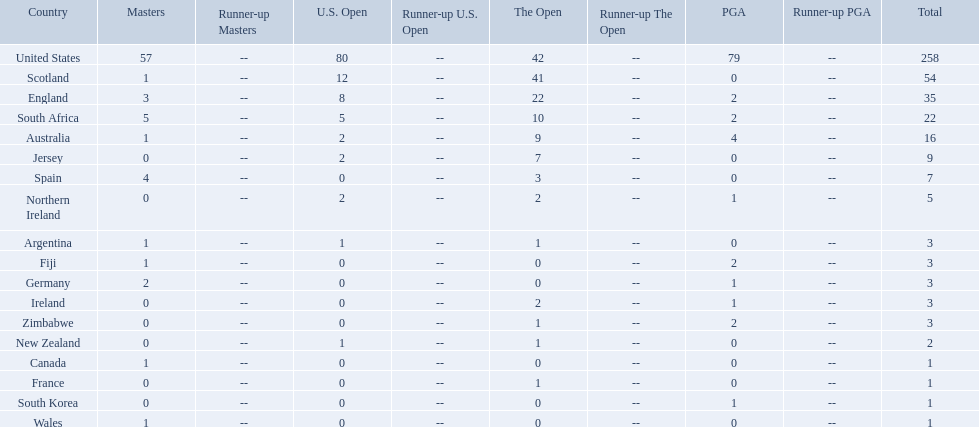Could you help me parse every detail presented in this table? {'header': ['Country', 'Masters', 'Runner-up Masters', 'U.S. Open', 'Runner-up U.S. Open', 'The Open', 'Runner-up The Open', 'PGA', 'Runner-up PGA', 'Total'], 'rows': [['United States', '57', '--', '80', '--', '42', '--', '79', '--', '258'], ['Scotland', '1', '--', '12', '--', '41', '--', '0', '--', '54'], ['England', '3', '--', '8', '--', '22', '--', '2', '--', '35'], ['South Africa', '5', '--', '5', '--', '10', '--', '2', '--', '22'], ['Australia', '1', '--', '2', '--', '9', '--', '4', '--', '16'], ['Jersey', '0', '--', '2', '--', '7', '--', '0', '--', '9'], ['Spain', '4', '--', '0', '--', '3', '--', '0', '--', '7'], ['Northern Ireland', '0', '--', '2', '--', '2', '--', '1', '--', '5'], ['Argentina', '1', '--', '1', '--', '1', '--', '0', '--', '3'], ['Fiji', '1', '--', '0', '--', '0', '--', '2', '--', '3'], ['Germany', '2', '--', '0', '--', '0', '--', '1', '--', '3'], ['Ireland', '0', '--', '0', '--', '2', '--', '1', '--', '3'], ['Zimbabwe', '0', '--', '0', '--', '1', '--', '2', '--', '3'], ['New Zealand', '0', '--', '1', '--', '1', '--', '0', '--', '2'], ['Canada', '1', '--', '0', '--', '0', '--', '0', '--', '1'], ['France', '0', '--', '0', '--', '1', '--', '0', '--', '1'], ['South Korea', '0', '--', '0', '--', '0', '--', '1', '--', '1'], ['Wales', '1', '--', '0', '--', '0', '--', '0', '--', '1']]} Which of the countries listed are african? South Africa, Zimbabwe. Which of those has the least championship winning golfers? Zimbabwe. 